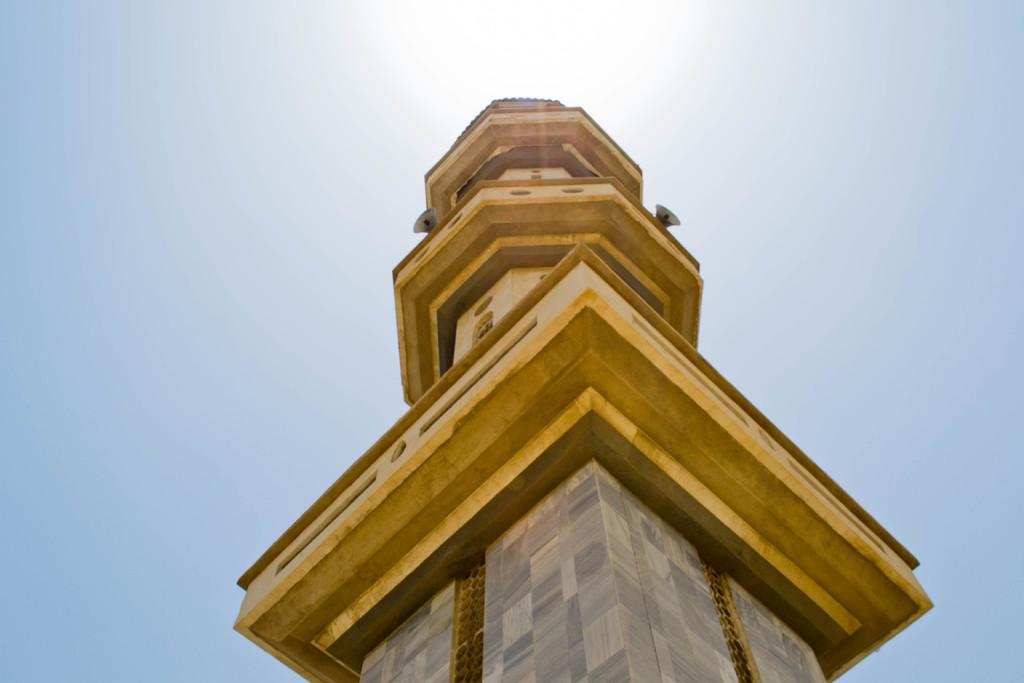What type of structure is present in the image? There is a building in the image. What colors can be seen on the building? The building has gold, brown, ash, and cream colors. What is the color of the sky in the image? The sky is blue and white in color. What type of pie is being served on the balcony of the building in the image? There is no pie or balcony present in the image; it only features a building with specific colors and a blue and white sky. 